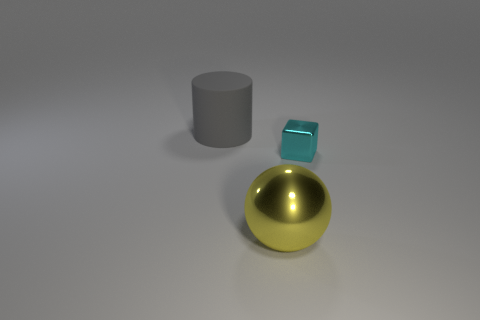There is a thing that is the same material as the small cyan block; what is its size?
Offer a terse response. Large. How big is the object to the right of the big thing right of the big gray matte cylinder?
Give a very brief answer. Small. Are there fewer big gray objects that are on the right side of the yellow thing than big objects?
Provide a succinct answer. Yes. How many other things are there of the same size as the cyan object?
Your answer should be compact. 0. There is a big object in front of the small cyan thing; does it have the same shape as the rubber thing?
Make the answer very short. No. Are there more cyan shiny cubes that are in front of the gray matte object than big yellow cylinders?
Offer a very short reply. Yes. The object that is both in front of the large cylinder and behind the big ball is made of what material?
Provide a short and direct response. Metal. Is there any other thing that has the same shape as the big gray matte thing?
Ensure brevity in your answer.  No. What number of shiny objects are on the left side of the tiny cube and behind the large yellow metallic sphere?
Ensure brevity in your answer.  0. What material is the cylinder?
Give a very brief answer. Rubber. 